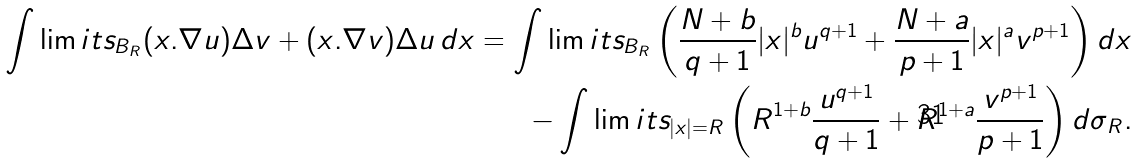<formula> <loc_0><loc_0><loc_500><loc_500>\int \lim i t s _ { B _ { R } } ( x . \nabla u ) \Delta v + ( x . \nabla v ) \Delta u \, d x = \int \lim i t s _ { B _ { R } } \left ( \frac { N + b } { q + 1 } | x | ^ { b } u ^ { q + 1 } + \frac { N + a } { p + 1 } | x | ^ { a } v ^ { p + 1 } \right ) d x \\ - \int \lim i t s _ { | x | = R } \left ( R ^ { 1 + b } \frac { u ^ { q + 1 } } { q + 1 } + R ^ { 1 + a } \frac { v ^ { p + 1 } } { p + 1 } \right ) d \sigma _ { R } .</formula> 